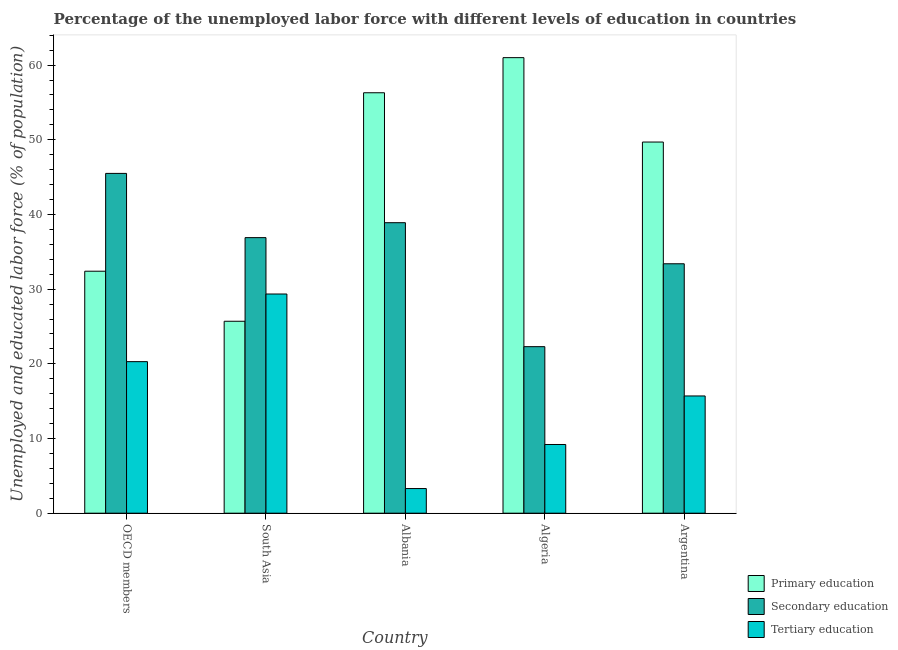How many different coloured bars are there?
Provide a short and direct response. 3. Are the number of bars on each tick of the X-axis equal?
Keep it short and to the point. Yes. How many bars are there on the 1st tick from the left?
Offer a terse response. 3. How many bars are there on the 5th tick from the right?
Give a very brief answer. 3. In how many cases, is the number of bars for a given country not equal to the number of legend labels?
Ensure brevity in your answer.  0. What is the percentage of labor force who received primary education in South Asia?
Your answer should be compact. 25.7. Across all countries, what is the maximum percentage of labor force who received tertiary education?
Offer a very short reply. 29.35. Across all countries, what is the minimum percentage of labor force who received tertiary education?
Your answer should be compact. 3.3. In which country was the percentage of labor force who received tertiary education maximum?
Your response must be concise. South Asia. In which country was the percentage of labor force who received secondary education minimum?
Ensure brevity in your answer.  Algeria. What is the total percentage of labor force who received tertiary education in the graph?
Offer a terse response. 77.85. What is the difference between the percentage of labor force who received tertiary education in Albania and that in Argentina?
Keep it short and to the point. -12.4. What is the difference between the percentage of labor force who received secondary education in Argentina and the percentage of labor force who received primary education in South Asia?
Offer a terse response. 7.7. What is the average percentage of labor force who received primary education per country?
Give a very brief answer. 45.02. What is the difference between the percentage of labor force who received tertiary education and percentage of labor force who received primary education in Algeria?
Your response must be concise. -51.8. In how many countries, is the percentage of labor force who received tertiary education greater than 52 %?
Keep it short and to the point. 0. What is the ratio of the percentage of labor force who received tertiary education in Argentina to that in OECD members?
Provide a succinct answer. 0.77. Is the percentage of labor force who received primary education in Argentina less than that in OECD members?
Offer a very short reply. No. Is the difference between the percentage of labor force who received primary education in Algeria and South Asia greater than the difference between the percentage of labor force who received secondary education in Algeria and South Asia?
Keep it short and to the point. Yes. What is the difference between the highest and the second highest percentage of labor force who received secondary education?
Offer a very short reply. 6.6. What is the difference between the highest and the lowest percentage of labor force who received secondary education?
Make the answer very short. 23.2. In how many countries, is the percentage of labor force who received primary education greater than the average percentage of labor force who received primary education taken over all countries?
Offer a very short reply. 3. What does the 3rd bar from the left in Argentina represents?
Your answer should be very brief. Tertiary education. What does the 3rd bar from the right in Albania represents?
Your answer should be compact. Primary education. Is it the case that in every country, the sum of the percentage of labor force who received primary education and percentage of labor force who received secondary education is greater than the percentage of labor force who received tertiary education?
Your answer should be very brief. Yes. Are all the bars in the graph horizontal?
Your answer should be compact. No. How many countries are there in the graph?
Provide a short and direct response. 5. What is the difference between two consecutive major ticks on the Y-axis?
Your answer should be compact. 10. Are the values on the major ticks of Y-axis written in scientific E-notation?
Ensure brevity in your answer.  No. Does the graph contain any zero values?
Make the answer very short. No. Where does the legend appear in the graph?
Offer a very short reply. Bottom right. What is the title of the graph?
Offer a very short reply. Percentage of the unemployed labor force with different levels of education in countries. What is the label or title of the Y-axis?
Ensure brevity in your answer.  Unemployed and educated labor force (% of population). What is the Unemployed and educated labor force (% of population) in Primary education in OECD members?
Keep it short and to the point. 32.4. What is the Unemployed and educated labor force (% of population) of Secondary education in OECD members?
Provide a short and direct response. 45.5. What is the Unemployed and educated labor force (% of population) of Tertiary education in OECD members?
Your answer should be compact. 20.29. What is the Unemployed and educated labor force (% of population) of Primary education in South Asia?
Ensure brevity in your answer.  25.7. What is the Unemployed and educated labor force (% of population) in Secondary education in South Asia?
Keep it short and to the point. 36.9. What is the Unemployed and educated labor force (% of population) of Tertiary education in South Asia?
Your answer should be compact. 29.35. What is the Unemployed and educated labor force (% of population) in Primary education in Albania?
Your answer should be compact. 56.3. What is the Unemployed and educated labor force (% of population) of Secondary education in Albania?
Offer a terse response. 38.9. What is the Unemployed and educated labor force (% of population) in Tertiary education in Albania?
Keep it short and to the point. 3.3. What is the Unemployed and educated labor force (% of population) of Primary education in Algeria?
Offer a terse response. 61. What is the Unemployed and educated labor force (% of population) of Secondary education in Algeria?
Provide a short and direct response. 22.3. What is the Unemployed and educated labor force (% of population) in Tertiary education in Algeria?
Your answer should be very brief. 9.2. What is the Unemployed and educated labor force (% of population) of Primary education in Argentina?
Provide a succinct answer. 49.7. What is the Unemployed and educated labor force (% of population) in Secondary education in Argentina?
Give a very brief answer. 33.4. What is the Unemployed and educated labor force (% of population) in Tertiary education in Argentina?
Provide a succinct answer. 15.7. Across all countries, what is the maximum Unemployed and educated labor force (% of population) in Primary education?
Your response must be concise. 61. Across all countries, what is the maximum Unemployed and educated labor force (% of population) in Secondary education?
Keep it short and to the point. 45.5. Across all countries, what is the maximum Unemployed and educated labor force (% of population) of Tertiary education?
Give a very brief answer. 29.35. Across all countries, what is the minimum Unemployed and educated labor force (% of population) of Primary education?
Give a very brief answer. 25.7. Across all countries, what is the minimum Unemployed and educated labor force (% of population) in Secondary education?
Keep it short and to the point. 22.3. Across all countries, what is the minimum Unemployed and educated labor force (% of population) of Tertiary education?
Your response must be concise. 3.3. What is the total Unemployed and educated labor force (% of population) in Primary education in the graph?
Make the answer very short. 225.11. What is the total Unemployed and educated labor force (% of population) of Secondary education in the graph?
Ensure brevity in your answer.  177. What is the total Unemployed and educated labor force (% of population) in Tertiary education in the graph?
Give a very brief answer. 77.85. What is the difference between the Unemployed and educated labor force (% of population) in Primary education in OECD members and that in South Asia?
Provide a succinct answer. 6.7. What is the difference between the Unemployed and educated labor force (% of population) in Secondary education in OECD members and that in South Asia?
Provide a succinct answer. 8.6. What is the difference between the Unemployed and educated labor force (% of population) in Tertiary education in OECD members and that in South Asia?
Your response must be concise. -9.06. What is the difference between the Unemployed and educated labor force (% of population) in Primary education in OECD members and that in Albania?
Offer a terse response. -23.9. What is the difference between the Unemployed and educated labor force (% of population) in Secondary education in OECD members and that in Albania?
Give a very brief answer. 6.6. What is the difference between the Unemployed and educated labor force (% of population) in Tertiary education in OECD members and that in Albania?
Your response must be concise. 16.99. What is the difference between the Unemployed and educated labor force (% of population) in Primary education in OECD members and that in Algeria?
Your answer should be compact. -28.6. What is the difference between the Unemployed and educated labor force (% of population) of Secondary education in OECD members and that in Algeria?
Offer a terse response. 23.2. What is the difference between the Unemployed and educated labor force (% of population) in Tertiary education in OECD members and that in Algeria?
Offer a terse response. 11.09. What is the difference between the Unemployed and educated labor force (% of population) of Primary education in OECD members and that in Argentina?
Offer a terse response. -17.3. What is the difference between the Unemployed and educated labor force (% of population) in Secondary education in OECD members and that in Argentina?
Ensure brevity in your answer.  12.1. What is the difference between the Unemployed and educated labor force (% of population) in Tertiary education in OECD members and that in Argentina?
Give a very brief answer. 4.59. What is the difference between the Unemployed and educated labor force (% of population) of Primary education in South Asia and that in Albania?
Offer a very short reply. -30.6. What is the difference between the Unemployed and educated labor force (% of population) in Secondary education in South Asia and that in Albania?
Provide a succinct answer. -2. What is the difference between the Unemployed and educated labor force (% of population) of Tertiary education in South Asia and that in Albania?
Offer a very short reply. 26.05. What is the difference between the Unemployed and educated labor force (% of population) in Primary education in South Asia and that in Algeria?
Give a very brief answer. -35.3. What is the difference between the Unemployed and educated labor force (% of population) of Secondary education in South Asia and that in Algeria?
Offer a terse response. 14.6. What is the difference between the Unemployed and educated labor force (% of population) in Tertiary education in South Asia and that in Algeria?
Provide a succinct answer. 20.15. What is the difference between the Unemployed and educated labor force (% of population) in Primary education in South Asia and that in Argentina?
Your answer should be compact. -24. What is the difference between the Unemployed and educated labor force (% of population) in Secondary education in South Asia and that in Argentina?
Ensure brevity in your answer.  3.5. What is the difference between the Unemployed and educated labor force (% of population) in Tertiary education in South Asia and that in Argentina?
Give a very brief answer. 13.65. What is the difference between the Unemployed and educated labor force (% of population) of Secondary education in Albania and that in Algeria?
Provide a short and direct response. 16.6. What is the difference between the Unemployed and educated labor force (% of population) in Tertiary education in Albania and that in Argentina?
Your response must be concise. -12.4. What is the difference between the Unemployed and educated labor force (% of population) of Primary education in Algeria and that in Argentina?
Provide a short and direct response. 11.3. What is the difference between the Unemployed and educated labor force (% of population) of Tertiary education in Algeria and that in Argentina?
Ensure brevity in your answer.  -6.5. What is the difference between the Unemployed and educated labor force (% of population) of Primary education in OECD members and the Unemployed and educated labor force (% of population) of Secondary education in South Asia?
Provide a short and direct response. -4.5. What is the difference between the Unemployed and educated labor force (% of population) in Primary education in OECD members and the Unemployed and educated labor force (% of population) in Tertiary education in South Asia?
Keep it short and to the point. 3.05. What is the difference between the Unemployed and educated labor force (% of population) of Secondary education in OECD members and the Unemployed and educated labor force (% of population) of Tertiary education in South Asia?
Offer a very short reply. 16.15. What is the difference between the Unemployed and educated labor force (% of population) of Primary education in OECD members and the Unemployed and educated labor force (% of population) of Secondary education in Albania?
Make the answer very short. -6.5. What is the difference between the Unemployed and educated labor force (% of population) of Primary education in OECD members and the Unemployed and educated labor force (% of population) of Tertiary education in Albania?
Provide a succinct answer. 29.1. What is the difference between the Unemployed and educated labor force (% of population) of Secondary education in OECD members and the Unemployed and educated labor force (% of population) of Tertiary education in Albania?
Your answer should be very brief. 42.2. What is the difference between the Unemployed and educated labor force (% of population) in Primary education in OECD members and the Unemployed and educated labor force (% of population) in Secondary education in Algeria?
Offer a very short reply. 10.1. What is the difference between the Unemployed and educated labor force (% of population) in Primary education in OECD members and the Unemployed and educated labor force (% of population) in Tertiary education in Algeria?
Give a very brief answer. 23.2. What is the difference between the Unemployed and educated labor force (% of population) in Secondary education in OECD members and the Unemployed and educated labor force (% of population) in Tertiary education in Algeria?
Ensure brevity in your answer.  36.3. What is the difference between the Unemployed and educated labor force (% of population) in Primary education in OECD members and the Unemployed and educated labor force (% of population) in Secondary education in Argentina?
Your answer should be very brief. -1. What is the difference between the Unemployed and educated labor force (% of population) in Primary education in OECD members and the Unemployed and educated labor force (% of population) in Tertiary education in Argentina?
Offer a terse response. 16.7. What is the difference between the Unemployed and educated labor force (% of population) of Secondary education in OECD members and the Unemployed and educated labor force (% of population) of Tertiary education in Argentina?
Your answer should be compact. 29.8. What is the difference between the Unemployed and educated labor force (% of population) in Primary education in South Asia and the Unemployed and educated labor force (% of population) in Secondary education in Albania?
Offer a very short reply. -13.2. What is the difference between the Unemployed and educated labor force (% of population) in Primary education in South Asia and the Unemployed and educated labor force (% of population) in Tertiary education in Albania?
Provide a short and direct response. 22.4. What is the difference between the Unemployed and educated labor force (% of population) in Secondary education in South Asia and the Unemployed and educated labor force (% of population) in Tertiary education in Albania?
Keep it short and to the point. 33.6. What is the difference between the Unemployed and educated labor force (% of population) in Primary education in South Asia and the Unemployed and educated labor force (% of population) in Secondary education in Algeria?
Keep it short and to the point. 3.4. What is the difference between the Unemployed and educated labor force (% of population) in Primary education in South Asia and the Unemployed and educated labor force (% of population) in Tertiary education in Algeria?
Give a very brief answer. 16.5. What is the difference between the Unemployed and educated labor force (% of population) of Secondary education in South Asia and the Unemployed and educated labor force (% of population) of Tertiary education in Algeria?
Ensure brevity in your answer.  27.7. What is the difference between the Unemployed and educated labor force (% of population) of Primary education in South Asia and the Unemployed and educated labor force (% of population) of Secondary education in Argentina?
Your response must be concise. -7.7. What is the difference between the Unemployed and educated labor force (% of population) in Primary education in South Asia and the Unemployed and educated labor force (% of population) in Tertiary education in Argentina?
Your answer should be very brief. 10. What is the difference between the Unemployed and educated labor force (% of population) in Secondary education in South Asia and the Unemployed and educated labor force (% of population) in Tertiary education in Argentina?
Provide a short and direct response. 21.2. What is the difference between the Unemployed and educated labor force (% of population) in Primary education in Albania and the Unemployed and educated labor force (% of population) in Secondary education in Algeria?
Your answer should be compact. 34. What is the difference between the Unemployed and educated labor force (% of population) in Primary education in Albania and the Unemployed and educated labor force (% of population) in Tertiary education in Algeria?
Make the answer very short. 47.1. What is the difference between the Unemployed and educated labor force (% of population) of Secondary education in Albania and the Unemployed and educated labor force (% of population) of Tertiary education in Algeria?
Give a very brief answer. 29.7. What is the difference between the Unemployed and educated labor force (% of population) of Primary education in Albania and the Unemployed and educated labor force (% of population) of Secondary education in Argentina?
Make the answer very short. 22.9. What is the difference between the Unemployed and educated labor force (% of population) in Primary education in Albania and the Unemployed and educated labor force (% of population) in Tertiary education in Argentina?
Your response must be concise. 40.6. What is the difference between the Unemployed and educated labor force (% of population) in Secondary education in Albania and the Unemployed and educated labor force (% of population) in Tertiary education in Argentina?
Keep it short and to the point. 23.2. What is the difference between the Unemployed and educated labor force (% of population) of Primary education in Algeria and the Unemployed and educated labor force (% of population) of Secondary education in Argentina?
Keep it short and to the point. 27.6. What is the difference between the Unemployed and educated labor force (% of population) of Primary education in Algeria and the Unemployed and educated labor force (% of population) of Tertiary education in Argentina?
Your answer should be compact. 45.3. What is the difference between the Unemployed and educated labor force (% of population) of Secondary education in Algeria and the Unemployed and educated labor force (% of population) of Tertiary education in Argentina?
Provide a short and direct response. 6.6. What is the average Unemployed and educated labor force (% of population) in Primary education per country?
Your response must be concise. 45.02. What is the average Unemployed and educated labor force (% of population) in Secondary education per country?
Give a very brief answer. 35.4. What is the average Unemployed and educated labor force (% of population) in Tertiary education per country?
Provide a succinct answer. 15.57. What is the difference between the Unemployed and educated labor force (% of population) of Primary education and Unemployed and educated labor force (% of population) of Secondary education in OECD members?
Your answer should be compact. -13.1. What is the difference between the Unemployed and educated labor force (% of population) of Primary education and Unemployed and educated labor force (% of population) of Tertiary education in OECD members?
Ensure brevity in your answer.  12.11. What is the difference between the Unemployed and educated labor force (% of population) in Secondary education and Unemployed and educated labor force (% of population) in Tertiary education in OECD members?
Ensure brevity in your answer.  25.21. What is the difference between the Unemployed and educated labor force (% of population) in Primary education and Unemployed and educated labor force (% of population) in Secondary education in South Asia?
Offer a very short reply. -11.2. What is the difference between the Unemployed and educated labor force (% of population) in Primary education and Unemployed and educated labor force (% of population) in Tertiary education in South Asia?
Keep it short and to the point. -3.65. What is the difference between the Unemployed and educated labor force (% of population) of Secondary education and Unemployed and educated labor force (% of population) of Tertiary education in South Asia?
Your answer should be compact. 7.55. What is the difference between the Unemployed and educated labor force (% of population) of Primary education and Unemployed and educated labor force (% of population) of Secondary education in Albania?
Offer a very short reply. 17.4. What is the difference between the Unemployed and educated labor force (% of population) of Secondary education and Unemployed and educated labor force (% of population) of Tertiary education in Albania?
Ensure brevity in your answer.  35.6. What is the difference between the Unemployed and educated labor force (% of population) in Primary education and Unemployed and educated labor force (% of population) in Secondary education in Algeria?
Your answer should be compact. 38.7. What is the difference between the Unemployed and educated labor force (% of population) in Primary education and Unemployed and educated labor force (% of population) in Tertiary education in Algeria?
Offer a very short reply. 51.8. What is the difference between the Unemployed and educated labor force (% of population) in Primary education and Unemployed and educated labor force (% of population) in Tertiary education in Argentina?
Give a very brief answer. 34. What is the difference between the Unemployed and educated labor force (% of population) in Secondary education and Unemployed and educated labor force (% of population) in Tertiary education in Argentina?
Your response must be concise. 17.7. What is the ratio of the Unemployed and educated labor force (% of population) in Primary education in OECD members to that in South Asia?
Your answer should be compact. 1.26. What is the ratio of the Unemployed and educated labor force (% of population) in Secondary education in OECD members to that in South Asia?
Provide a short and direct response. 1.23. What is the ratio of the Unemployed and educated labor force (% of population) of Tertiary education in OECD members to that in South Asia?
Make the answer very short. 0.69. What is the ratio of the Unemployed and educated labor force (% of population) of Primary education in OECD members to that in Albania?
Offer a terse response. 0.58. What is the ratio of the Unemployed and educated labor force (% of population) in Secondary education in OECD members to that in Albania?
Your answer should be compact. 1.17. What is the ratio of the Unemployed and educated labor force (% of population) in Tertiary education in OECD members to that in Albania?
Your answer should be very brief. 6.15. What is the ratio of the Unemployed and educated labor force (% of population) in Primary education in OECD members to that in Algeria?
Keep it short and to the point. 0.53. What is the ratio of the Unemployed and educated labor force (% of population) of Secondary education in OECD members to that in Algeria?
Keep it short and to the point. 2.04. What is the ratio of the Unemployed and educated labor force (% of population) of Tertiary education in OECD members to that in Algeria?
Your answer should be compact. 2.21. What is the ratio of the Unemployed and educated labor force (% of population) of Primary education in OECD members to that in Argentina?
Ensure brevity in your answer.  0.65. What is the ratio of the Unemployed and educated labor force (% of population) of Secondary education in OECD members to that in Argentina?
Offer a very short reply. 1.36. What is the ratio of the Unemployed and educated labor force (% of population) in Tertiary education in OECD members to that in Argentina?
Make the answer very short. 1.29. What is the ratio of the Unemployed and educated labor force (% of population) in Primary education in South Asia to that in Albania?
Your answer should be compact. 0.46. What is the ratio of the Unemployed and educated labor force (% of population) of Secondary education in South Asia to that in Albania?
Your answer should be very brief. 0.95. What is the ratio of the Unemployed and educated labor force (% of population) of Tertiary education in South Asia to that in Albania?
Keep it short and to the point. 8.89. What is the ratio of the Unemployed and educated labor force (% of population) in Primary education in South Asia to that in Algeria?
Offer a terse response. 0.42. What is the ratio of the Unemployed and educated labor force (% of population) of Secondary education in South Asia to that in Algeria?
Offer a terse response. 1.65. What is the ratio of the Unemployed and educated labor force (% of population) in Tertiary education in South Asia to that in Algeria?
Your answer should be compact. 3.19. What is the ratio of the Unemployed and educated labor force (% of population) in Primary education in South Asia to that in Argentina?
Keep it short and to the point. 0.52. What is the ratio of the Unemployed and educated labor force (% of population) of Secondary education in South Asia to that in Argentina?
Your answer should be very brief. 1.1. What is the ratio of the Unemployed and educated labor force (% of population) of Tertiary education in South Asia to that in Argentina?
Provide a succinct answer. 1.87. What is the ratio of the Unemployed and educated labor force (% of population) of Primary education in Albania to that in Algeria?
Offer a very short reply. 0.92. What is the ratio of the Unemployed and educated labor force (% of population) of Secondary education in Albania to that in Algeria?
Offer a very short reply. 1.74. What is the ratio of the Unemployed and educated labor force (% of population) in Tertiary education in Albania to that in Algeria?
Make the answer very short. 0.36. What is the ratio of the Unemployed and educated labor force (% of population) of Primary education in Albania to that in Argentina?
Make the answer very short. 1.13. What is the ratio of the Unemployed and educated labor force (% of population) in Secondary education in Albania to that in Argentina?
Make the answer very short. 1.16. What is the ratio of the Unemployed and educated labor force (% of population) of Tertiary education in Albania to that in Argentina?
Your response must be concise. 0.21. What is the ratio of the Unemployed and educated labor force (% of population) in Primary education in Algeria to that in Argentina?
Offer a terse response. 1.23. What is the ratio of the Unemployed and educated labor force (% of population) in Secondary education in Algeria to that in Argentina?
Provide a short and direct response. 0.67. What is the ratio of the Unemployed and educated labor force (% of population) of Tertiary education in Algeria to that in Argentina?
Your answer should be compact. 0.59. What is the difference between the highest and the second highest Unemployed and educated labor force (% of population) of Primary education?
Make the answer very short. 4.7. What is the difference between the highest and the second highest Unemployed and educated labor force (% of population) of Secondary education?
Your answer should be very brief. 6.6. What is the difference between the highest and the second highest Unemployed and educated labor force (% of population) in Tertiary education?
Provide a short and direct response. 9.06. What is the difference between the highest and the lowest Unemployed and educated labor force (% of population) in Primary education?
Give a very brief answer. 35.3. What is the difference between the highest and the lowest Unemployed and educated labor force (% of population) in Secondary education?
Provide a short and direct response. 23.2. What is the difference between the highest and the lowest Unemployed and educated labor force (% of population) of Tertiary education?
Your response must be concise. 26.05. 